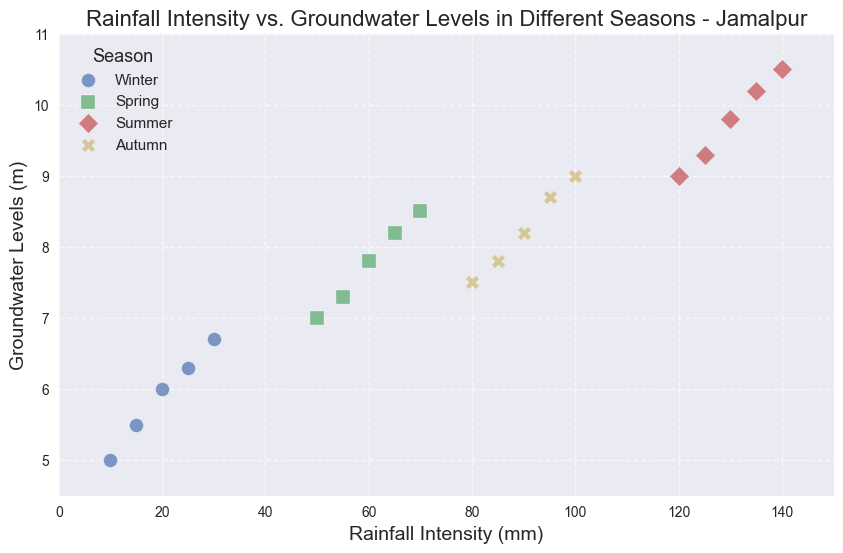Which season shows the highest groundwater levels? By observing the plotted points, the season with the highest groundwater levels is summer, reaching up to 10.5 meters.
Answer: Summer During which season is the rainfall intensity and groundwater level correlation the weakest? The scatter plot shows less consistent correlation in Autumn, where points seem more spread out compared to other seasons.
Answer: Autumn What is the range of groundwater levels in Winter? The minimum groundwater level for Winter is 5.0 meters and the maximum is 6.7 meters. So, the range is 6.7 - 5.0 = 1.7 meters.
Answer: 1.7 meters Which two seasons exhibit the most overlapping of rainfall intensities in the plot? Both Spring and Autumn have rainfall intensities in between 50mm to 100mm, therefore they exhibit the most overlap in this range.
Answer: Spring and Autumn How does the groundwater level change as the rainfall intensity increases from 10mm to 30mm in Winter? Winter data shows groundwater levels increasing from 5.0 meters to 6.7 meters as rainfall intensity increases from 10mm to 30mm.
Answer: Increases Compare the steepness of the groundwater level rise between Spring and Summer. Which one rises more rapidly? By examining the slope of the points, Summer shows a steeper (more rapid) increase from 9.0m to 10.5m as opposed to Spring which rises from 7.0m to 8.5m over a similar rainfall intensity range.
Answer: Summer What is the average groundwater level in Spring? The groundwater levels in Spring are 7.0, 7.3, 7.8, 8.2, and 8.5. Adding these, we get 7.0 + 7.3 + 7.8 + 8.2 + 8.5 = 38.8. Dividing by 5, we get 38.8 / 5 = 7.76 meters.
Answer: 7.76 meters Is there any noticeable trend of groundwater levels in response to rainfall intensity in Summer? Each data point for Summer shows that as the rainfall increases from 120mm to 140mm, groundwater levels consistently rise from 9.0 meters to 10.5 meters indicating a positive correlation.
Answer: Positive correlation Which season has the least increase in groundwater levels per unit increase in rainfall intensity? Winter shows less sharp increments; from 10mm to 30mm, the groundwater level only rises 1.7 meters, making it the season with the least increase per unit rainfall intensity.
Answer: Winter What is the visual attribute used to distinguish different seasons in the scatter plot? Different markers (o, s, D, X) and colors (blue, green, red, yellow) are used to distinguish between Winter, Spring, Summer, and Autumn respectively.
Answer: Markers and colors 